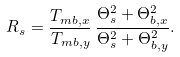Convert formula to latex. <formula><loc_0><loc_0><loc_500><loc_500>R _ { s } = \frac { T _ { m b , x } } { T _ { m b , y } } \, \frac { \Theta _ { s } ^ { 2 } + \Theta _ { b , x } ^ { 2 } } { \Theta _ { s } ^ { 2 } + \Theta _ { b , y } ^ { 2 } } .</formula> 